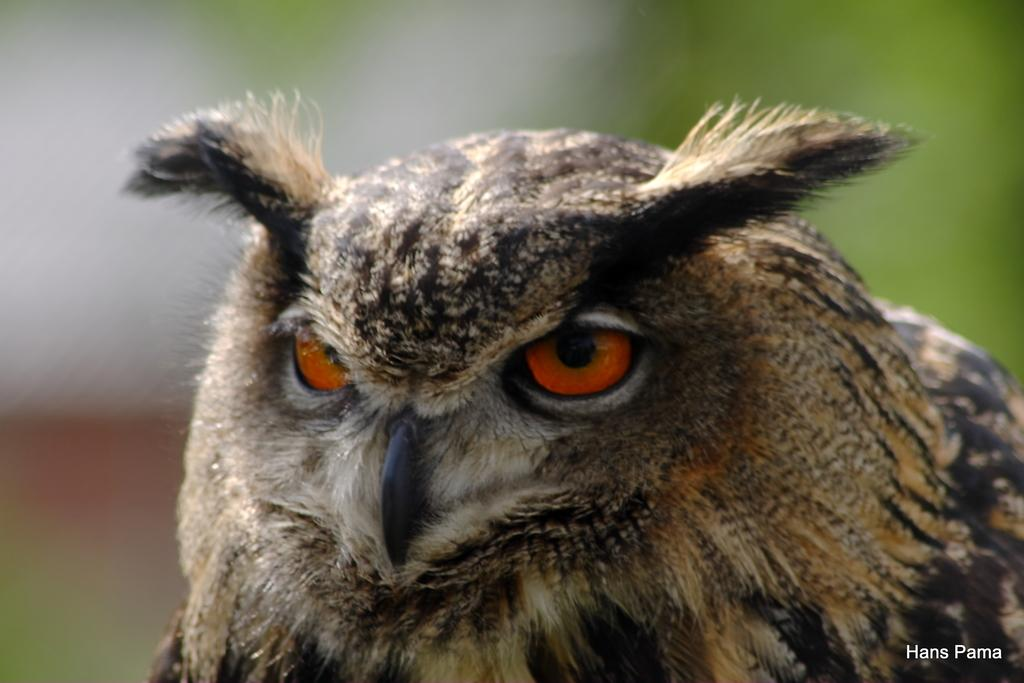What type of animal is in the image? There is a bird in the image. Can you describe the bird's coloring? The bird has brown and black colors. What can be observed about the background of the image? The background of the image is blurred. What type of pen is the bird holding in the image? There is no pen present in the image; it features a bird with brown and black colors against a blurred background. 